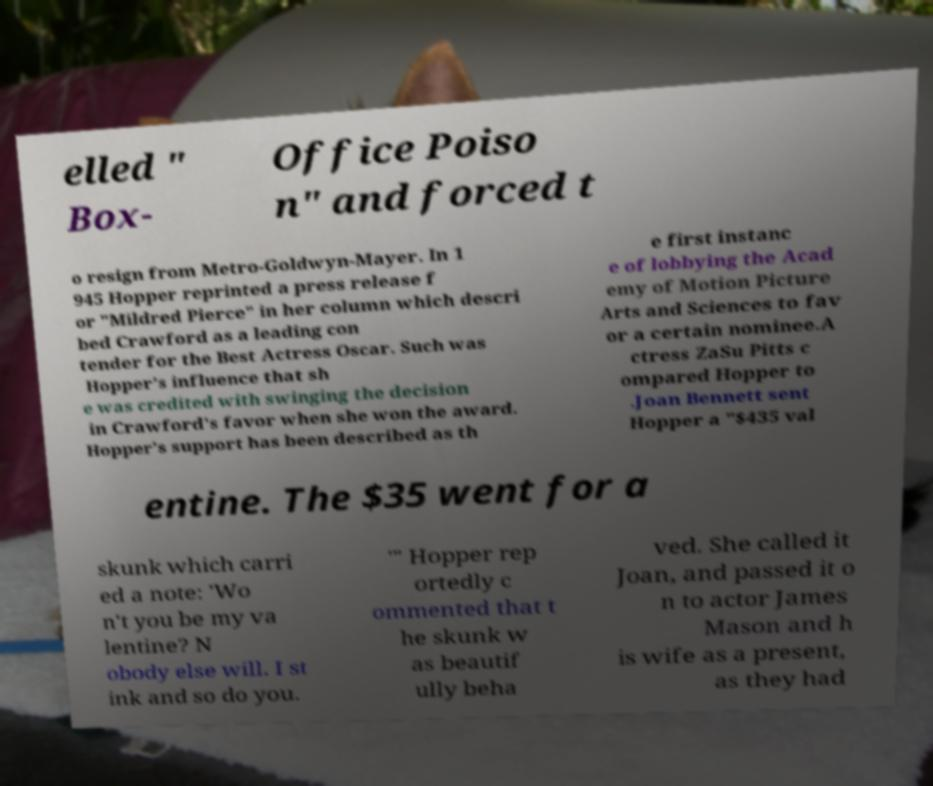Could you extract and type out the text from this image? elled " Box- Office Poiso n" and forced t o resign from Metro-Goldwyn-Mayer. In 1 945 Hopper reprinted a press release f or "Mildred Pierce" in her column which descri bed Crawford as a leading con tender for the Best Actress Oscar. Such was Hopper's influence that sh e was credited with swinging the decision in Crawford's favor when she won the award. Hopper's support has been described as th e first instanc e of lobbying the Acad emy of Motion Picture Arts and Sciences to fav or a certain nominee.A ctress ZaSu Pitts c ompared Hopper to .Joan Bennett sent Hopper a "$435 val entine. The $35 went for a skunk which carri ed a note: 'Wo n't you be my va lentine? N obody else will. I st ink and so do you. '" Hopper rep ortedly c ommented that t he skunk w as beautif ully beha ved. She called it Joan, and passed it o n to actor James Mason and h is wife as a present, as they had 